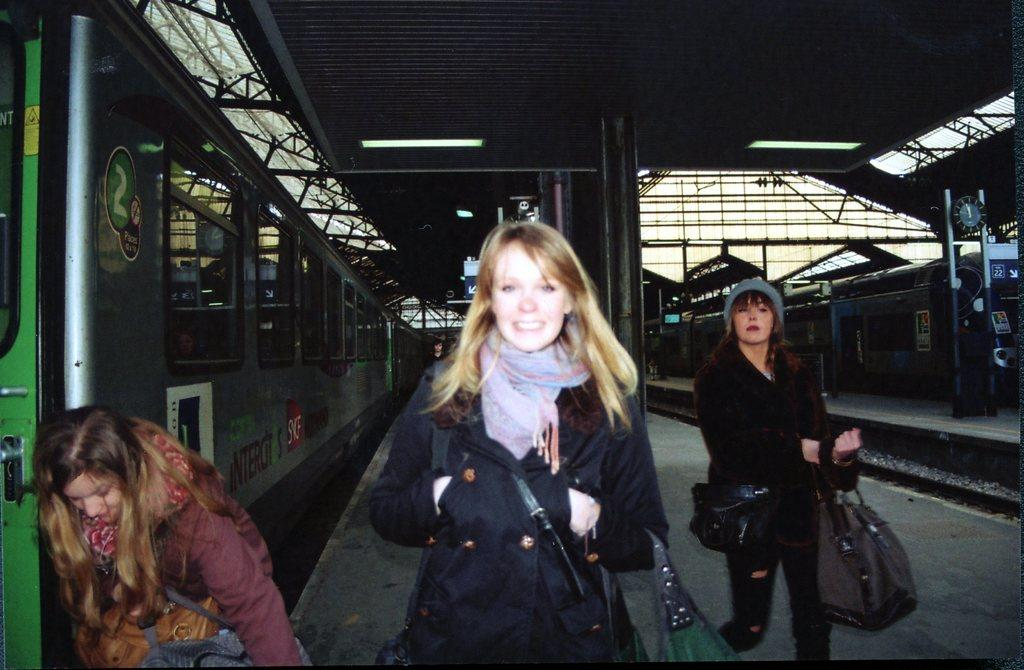How many women are in the image? There are three women in the image. Where are the women located in the image? The women are on a platform. What can be seen on both sides of the image? There is a train on the left side and another train on the right side of the image. What is above the platform in the image? There is a roof above the platform. What type of brass instrument is being played by one of the women in the image? There is no brass instrument or any musical instrument being played in the image. Can you see any clovers growing on the platform in the image? There are no clovers or plants visible on the platform in the image. 